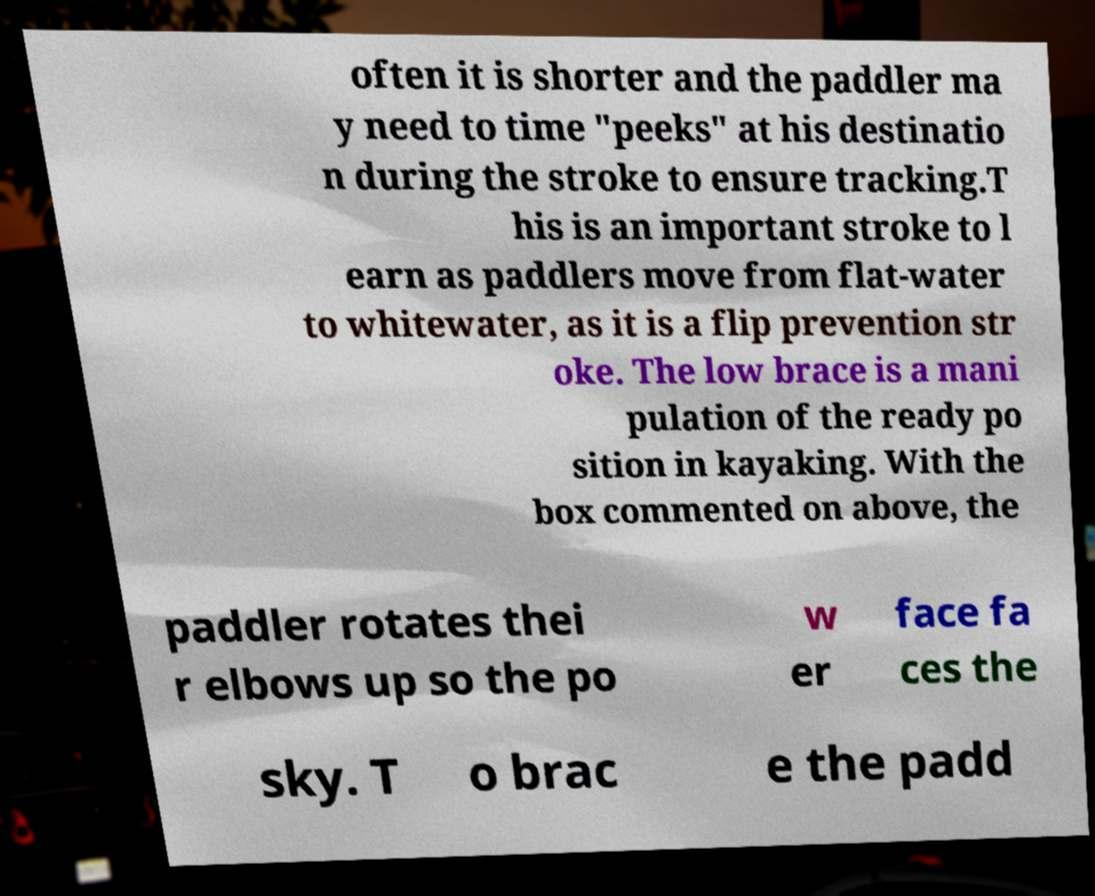Can you read and provide the text displayed in the image?This photo seems to have some interesting text. Can you extract and type it out for me? often it is shorter and the paddler ma y need to time "peeks" at his destinatio n during the stroke to ensure tracking.T his is an important stroke to l earn as paddlers move from flat-water to whitewater, as it is a flip prevention str oke. The low brace is a mani pulation of the ready po sition in kayaking. With the box commented on above, the paddler rotates thei r elbows up so the po w er face fa ces the sky. T o brac e the padd 